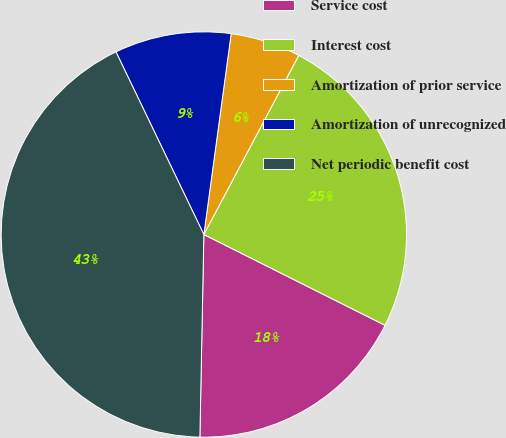<chart> <loc_0><loc_0><loc_500><loc_500><pie_chart><fcel>Service cost<fcel>Interest cost<fcel>Amortization of prior service<fcel>Amortization of unrecognized<fcel>Net periodic benefit cost<nl><fcel>17.92%<fcel>24.64%<fcel>5.6%<fcel>9.29%<fcel>42.55%<nl></chart> 